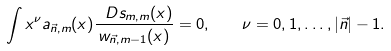<formula> <loc_0><loc_0><loc_500><loc_500>\int x ^ { \nu } a _ { \vec { n } , m } ( x ) \frac { \ D s _ { m , m } ( x ) } { w _ { \vec { n } , m - 1 } ( x ) } = 0 , \quad \nu = 0 , 1 , \dots , | \vec { n } | - 1 .</formula> 